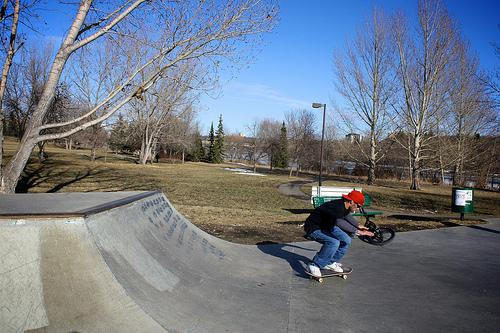Question: who is on the skateboard?
Choices:
A. The pilgrim.
B. The man.
C. Jason Bateman.
D. Jason Lee.
Answer with the letter. Answer: B Question: when was the picture taken?
Choices:
A. Night.
B. Sunset.
C. Daytime.
D. New Year's eve.
Answer with the letter. Answer: C Question: where is the man?
Choices:
A. In the ocean.
B. On the beach.
C. On the skateboard.
D. At work.
Answer with the letter. Answer: C Question: what color is the sky?
Choices:
A. White.
B. Blue.
C. Clear.
D. Grey.
Answer with the letter. Answer: B 